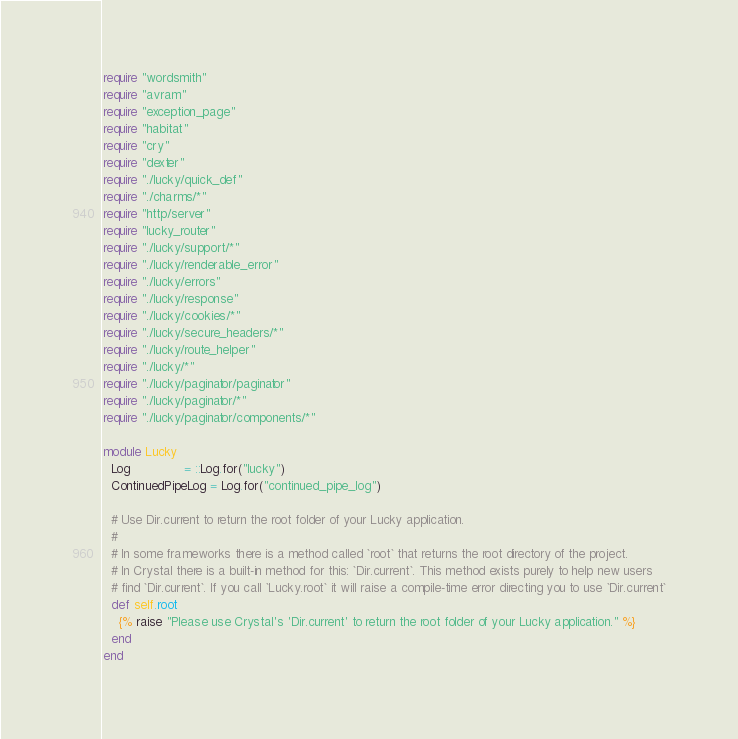Convert code to text. <code><loc_0><loc_0><loc_500><loc_500><_Crystal_>require "wordsmith"
require "avram"
require "exception_page"
require "habitat"
require "cry"
require "dexter"
require "./lucky/quick_def"
require "./charms/*"
require "http/server"
require "lucky_router"
require "./lucky/support/*"
require "./lucky/renderable_error"
require "./lucky/errors"
require "./lucky/response"
require "./lucky/cookies/*"
require "./lucky/secure_headers/*"
require "./lucky/route_helper"
require "./lucky/*"
require "./lucky/paginator/paginator"
require "./lucky/paginator/*"
require "./lucky/paginator/components/*"

module Lucky
  Log              = ::Log.for("lucky")
  ContinuedPipeLog = Log.for("continued_pipe_log")

  # Use Dir.current to return the root folder of your Lucky application.
  #
  # In some frameworks there is a method called `root` that returns the root directory of the project.
  # In Crystal there is a built-in method for this: `Dir.current`. This method exists purely to help new users
  # find `Dir.current`. If you call `Lucky.root` it will raise a compile-time error directing you to use `Dir.current`
  def self.root
    {% raise "Please use Crystal's 'Dir.current' to return the root folder of your Lucky application." %}
  end
end
</code> 